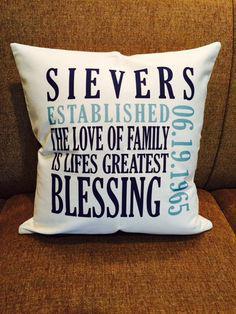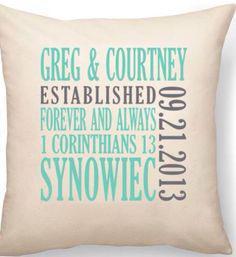The first image is the image on the left, the second image is the image on the right. For the images shown, is this caption "There are an even number of pillows and no people." true? Answer yes or no. Yes. The first image is the image on the left, the second image is the image on the right. Examine the images to the left and right. Is the description "The large squarish item in the foreground of one image is stamped at the center with a single alphabet letter." accurate? Answer yes or no. No. 